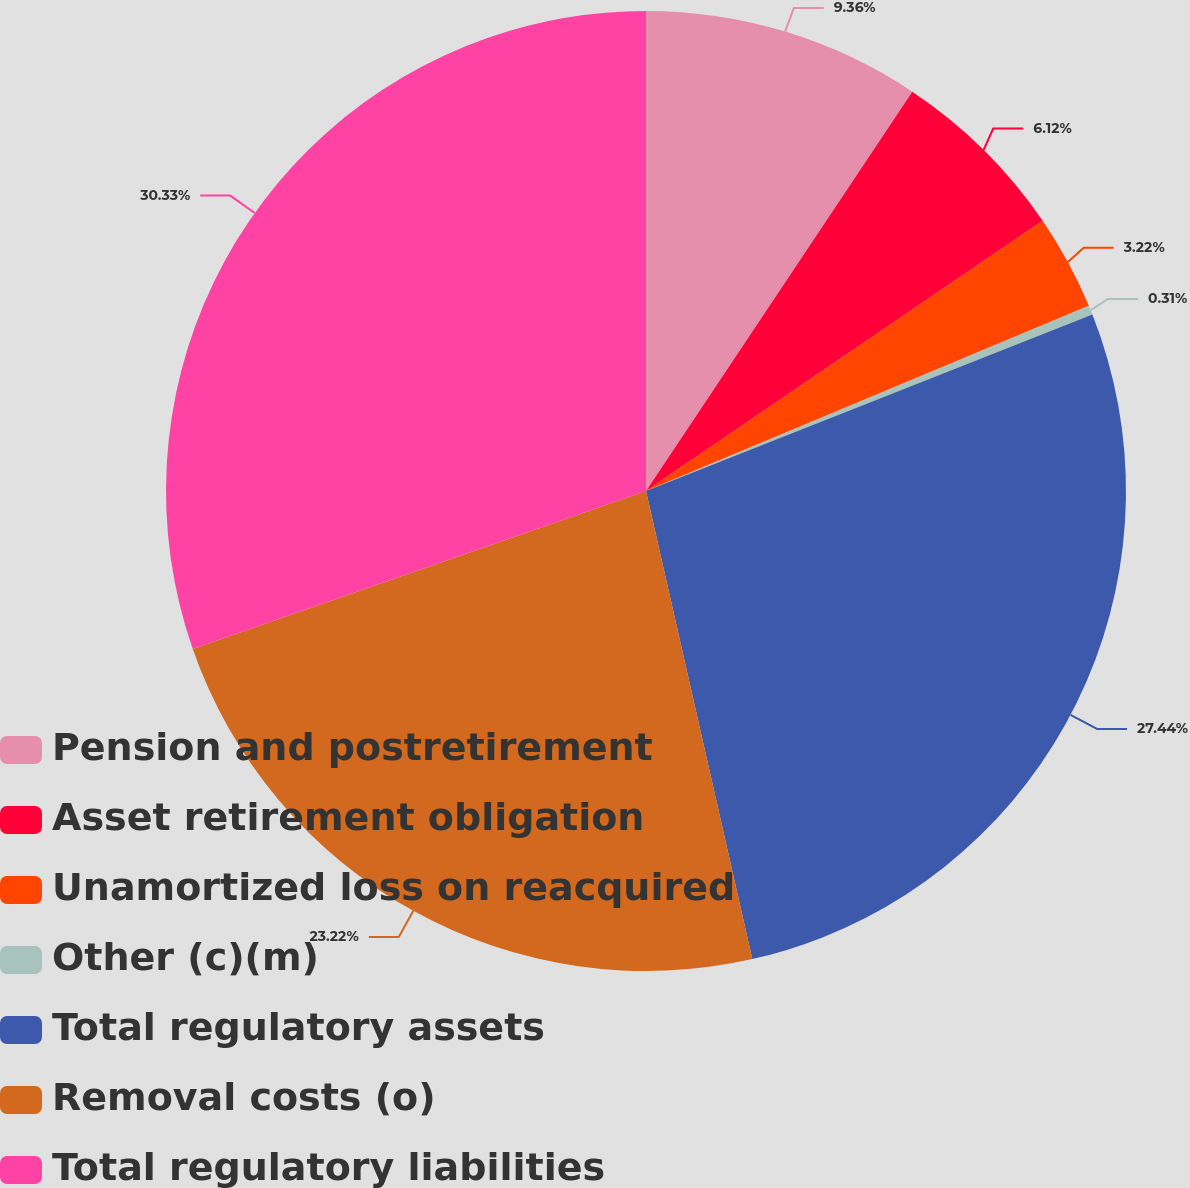Convert chart. <chart><loc_0><loc_0><loc_500><loc_500><pie_chart><fcel>Pension and postretirement<fcel>Asset retirement obligation<fcel>Unamortized loss on reacquired<fcel>Other (c)(m)<fcel>Total regulatory assets<fcel>Removal costs (o)<fcel>Total regulatory liabilities<nl><fcel>9.36%<fcel>6.12%<fcel>3.22%<fcel>0.31%<fcel>27.44%<fcel>23.22%<fcel>30.34%<nl></chart> 